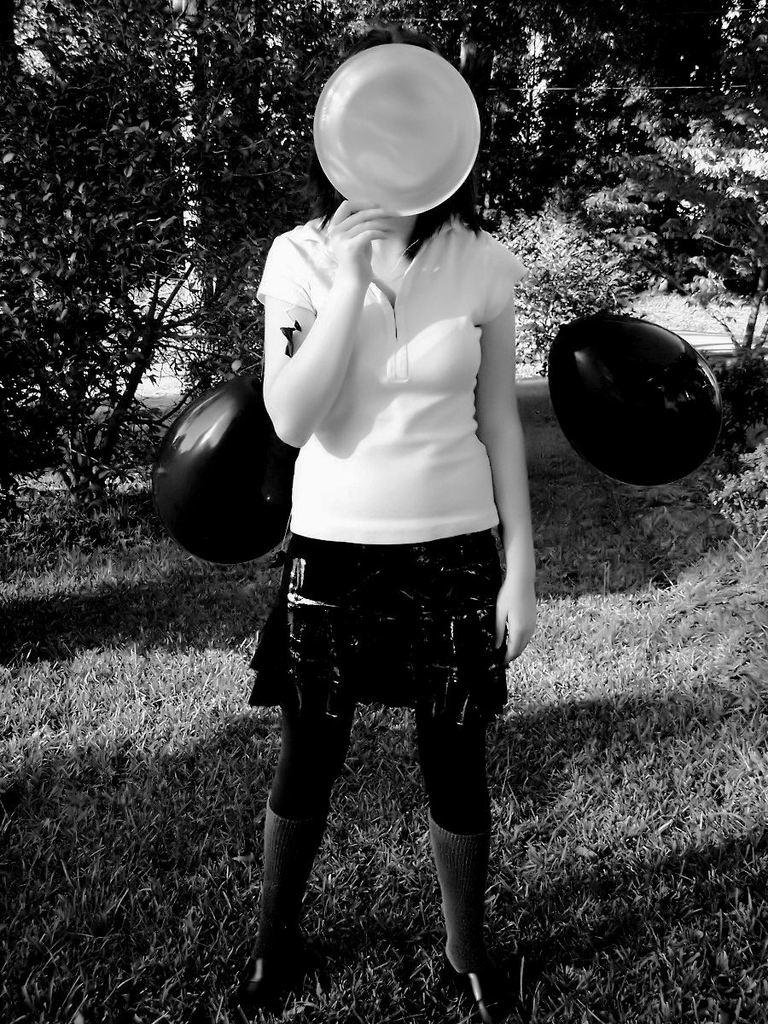What is the main subject of the image? The main subject of the image is a woman. What is the woman doing in the image? The woman is standing and covering her face with a plate. What type of clothing is the woman wearing? The woman is wearing a t-shirt and shoes. What can be seen in the background of the image? There are trees in the background of the image. What is the color scheme of the image? The image is black and white. What type of animal is hiding behind the trees in the image? There is no animal present in the image; it only features a woman and trees in the background. 